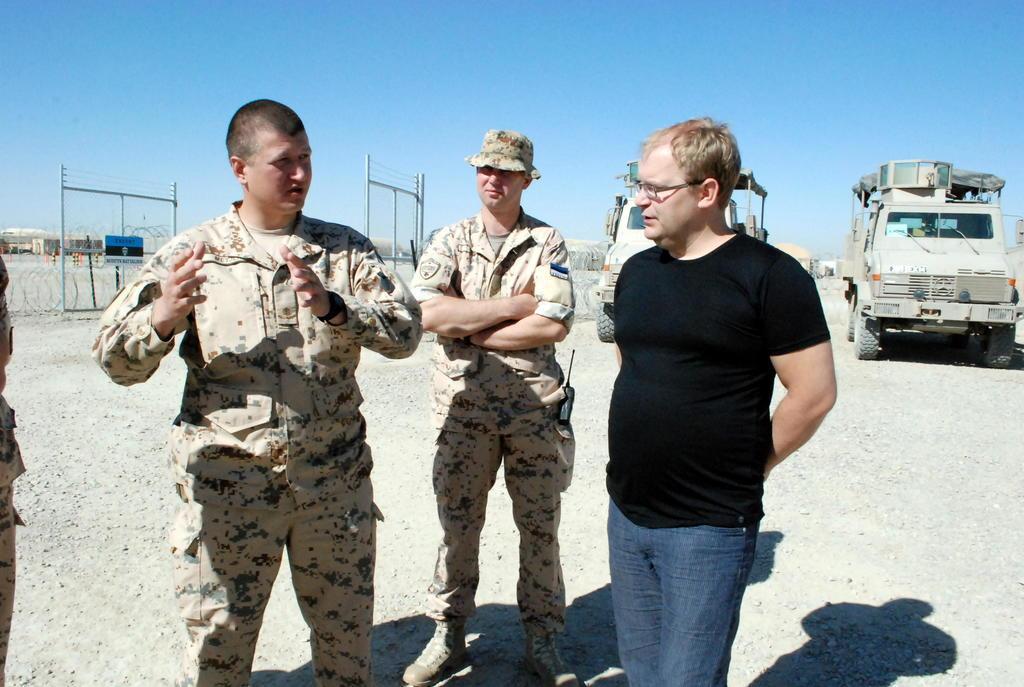How would you summarize this image in a sentence or two? In this image I can see two men wearing uniforms are standing and another person wearing black t shirt and blue jeans is standing on the ground. In the background I can see the fencing, few vehicles, few buildings and the sky. 